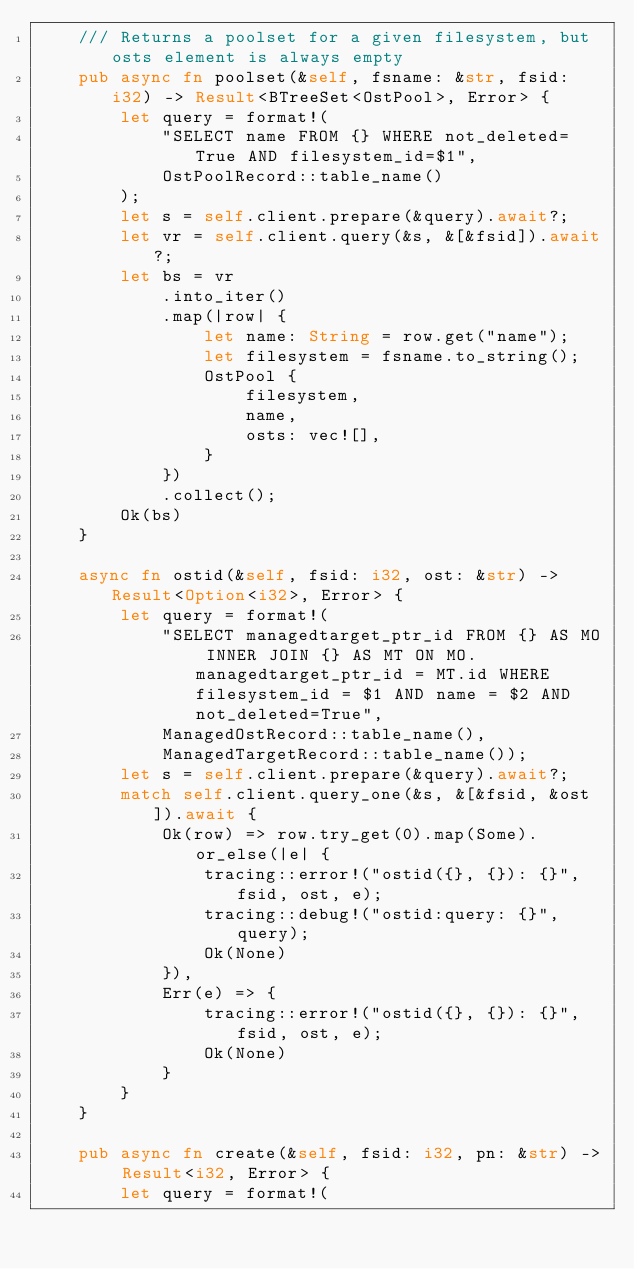Convert code to text. <code><loc_0><loc_0><loc_500><loc_500><_Rust_>    /// Returns a poolset for a given filesystem, but osts element is always empty
    pub async fn poolset(&self, fsname: &str, fsid: i32) -> Result<BTreeSet<OstPool>, Error> {
        let query = format!(
            "SELECT name FROM {} WHERE not_deleted=True AND filesystem_id=$1",
            OstPoolRecord::table_name()
        );
        let s = self.client.prepare(&query).await?;
        let vr = self.client.query(&s, &[&fsid]).await?;
        let bs = vr
            .into_iter()
            .map(|row| {
                let name: String = row.get("name");
                let filesystem = fsname.to_string();
                OstPool {
                    filesystem,
                    name,
                    osts: vec![],
                }
            })
            .collect();
        Ok(bs)
    }

    async fn ostid(&self, fsid: i32, ost: &str) -> Result<Option<i32>, Error> {
        let query = format!(
            "SELECT managedtarget_ptr_id FROM {} AS MO INNER JOIN {} AS MT ON MO.managedtarget_ptr_id = MT.id WHERE filesystem_id = $1 AND name = $2 AND not_deleted=True",
            ManagedOstRecord::table_name(),
            ManagedTargetRecord::table_name());
        let s = self.client.prepare(&query).await?;
        match self.client.query_one(&s, &[&fsid, &ost]).await {
            Ok(row) => row.try_get(0).map(Some).or_else(|e| {
                tracing::error!("ostid({}, {}): {}", fsid, ost, e);
                tracing::debug!("ostid:query: {}", query);
                Ok(None)
            }),
            Err(e) => {
                tracing::error!("ostid({}, {}): {}", fsid, ost, e);
                Ok(None)
            }
        }
    }

    pub async fn create(&self, fsid: i32, pn: &str) -> Result<i32, Error> {
        let query = format!(</code> 